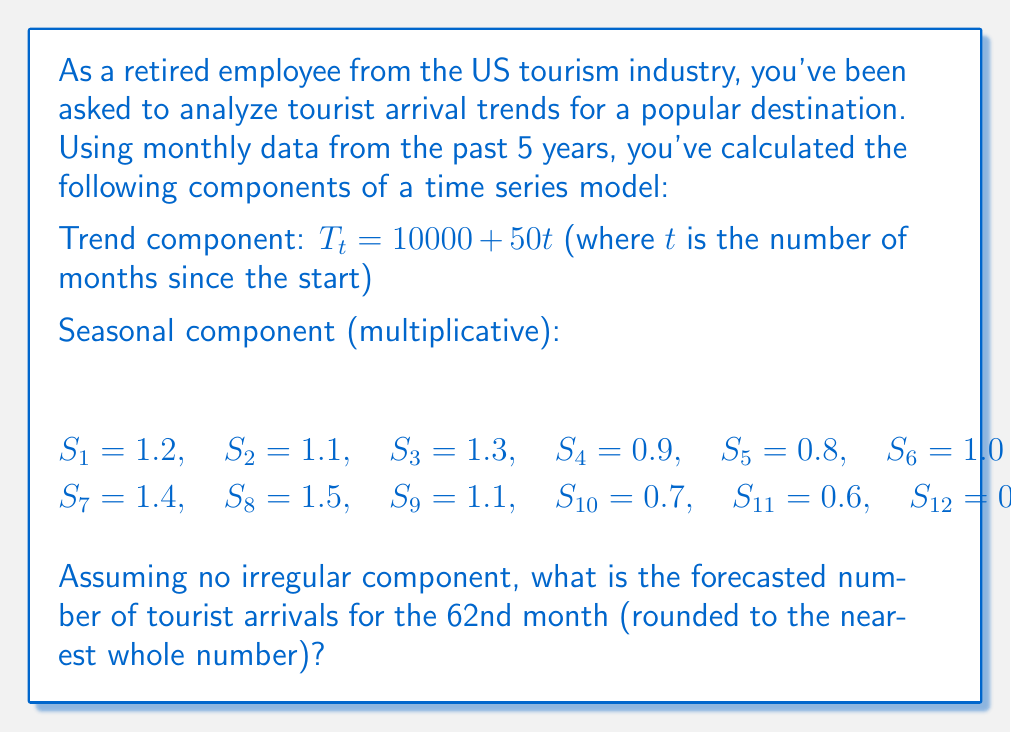Provide a solution to this math problem. To solve this problem, we'll use the multiplicative time series model:

$$ Y_t = T_t \times S_t $$

Where:
$Y_t$ is the forecasted value
$T_t$ is the trend component
$S_t$ is the seasonal component

Steps to solve:

1. Calculate the trend component for the 62nd month:
   $$ T_{62} = 10000 + 50(62) = 10000 + 3100 = 13100 $$

2. Determine the seasonal factor for the 62nd month:
   62 ≡ 2 (mod 12), so we use $S_2 = 1.1$

3. Apply the multiplicative model:
   $$ Y_{62} = T_{62} \times S_2 = 13100 \times 1.1 = 14410 $$

4. Round to the nearest whole number:
   14410 rounds to 14410

Therefore, the forecasted number of tourist arrivals for the 62nd month is 14,410.
Answer: 14,410 